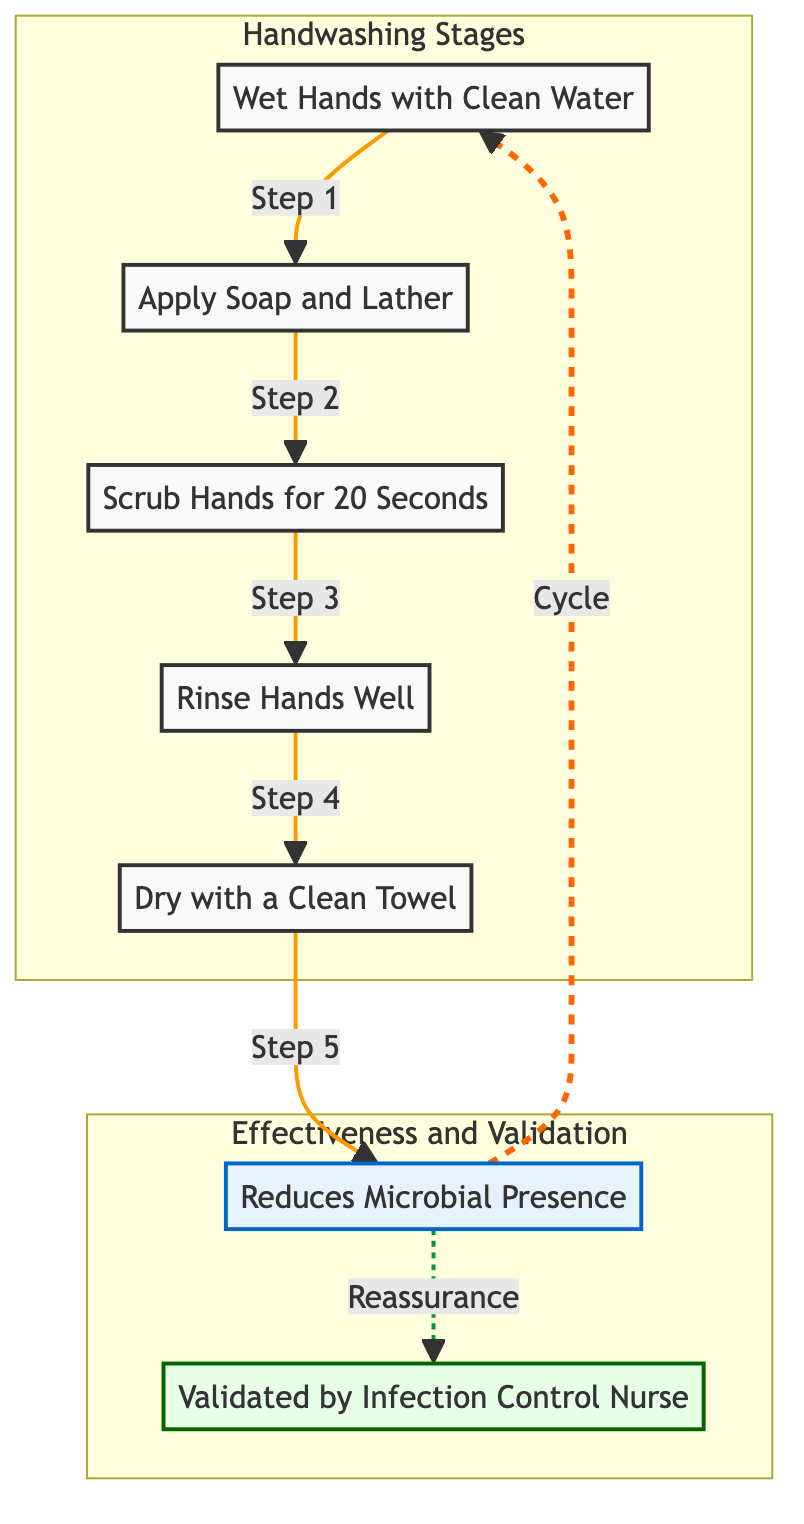What are the five stages of hand hygiene? The diagram outlines five distinct stages of hand hygiene: Wet Hands with Clean Water, Apply Soap and Lather, Scrub Hands for 20 Seconds, Rinse Hands Well, and Dry with a Clean Towel.
Answer: Wet Hands with Clean Water, Apply Soap and Lather, Scrub Hands for 20 Seconds, Rinse Hands Well, Dry with a Clean Towel How many total nodes are in the diagram? To determine the total number of nodes, we count the distinct actions and outcomes represented. The nodes include five stages, one effectiveness node, and one validation node, which gives a total of seven nodes.
Answer: 7 What action follows after "Scrub Hands for 20 Seconds"? According to the flow of the diagram, the action that follows "Scrub Hands for 20 Seconds" is "Rinse Hands Well". This is indicated by the directed arrow showing progress in the process.
Answer: Rinse Hands Well What does the effectiveness node indicate? The effectiveness node labeled "Reduces Microbial Presence" indicates the outcome of completing the hand hygiene process, signifying a reduction in microbial levels. This node emphasizes the importance of the entire cycle in achieving cleanliness.
Answer: Reduces Microbial Presence Which node validates the process according to the diagram? The node that validates the process is labeled "Validated by Infection Control Nurse". This shows that a healthcare professional's confirmation is included in the cyclical process, reinforcing its reliability.
Answer: Validated by Infection Control Nurse What is the relationship between "Reduces Microbial Presence" and "Validated by Infection Control Nurse"? The diagram shows a dashed line representing reassurance between the effectiveness of hand hygiene and its validation, indicating a supportive relationship where effectiveness leads to a professional validation.
Answer: Reassurance What is the significance of "Dry with a Clean Towel" in the process? "Dry with a Clean Towel" is the final action in the hand hygiene process, preceding the effectiveness node. It is crucial as it completes the hygiene cycle and ensures that hands are not only clean but also free of excess moisture, which can harbor microbes.
Answer: Final action How is the cyclical nature of the diagram represented? The cyclical nature is depicted by the arrow going from the effectiveness node "Reduces Microbial Presence" back to "Wet Hands with Clean Water". This indicates that the hand hygiene process can be repeated continuously to maintain cleanliness and microbial reduction.
Answer: Cyclical process 